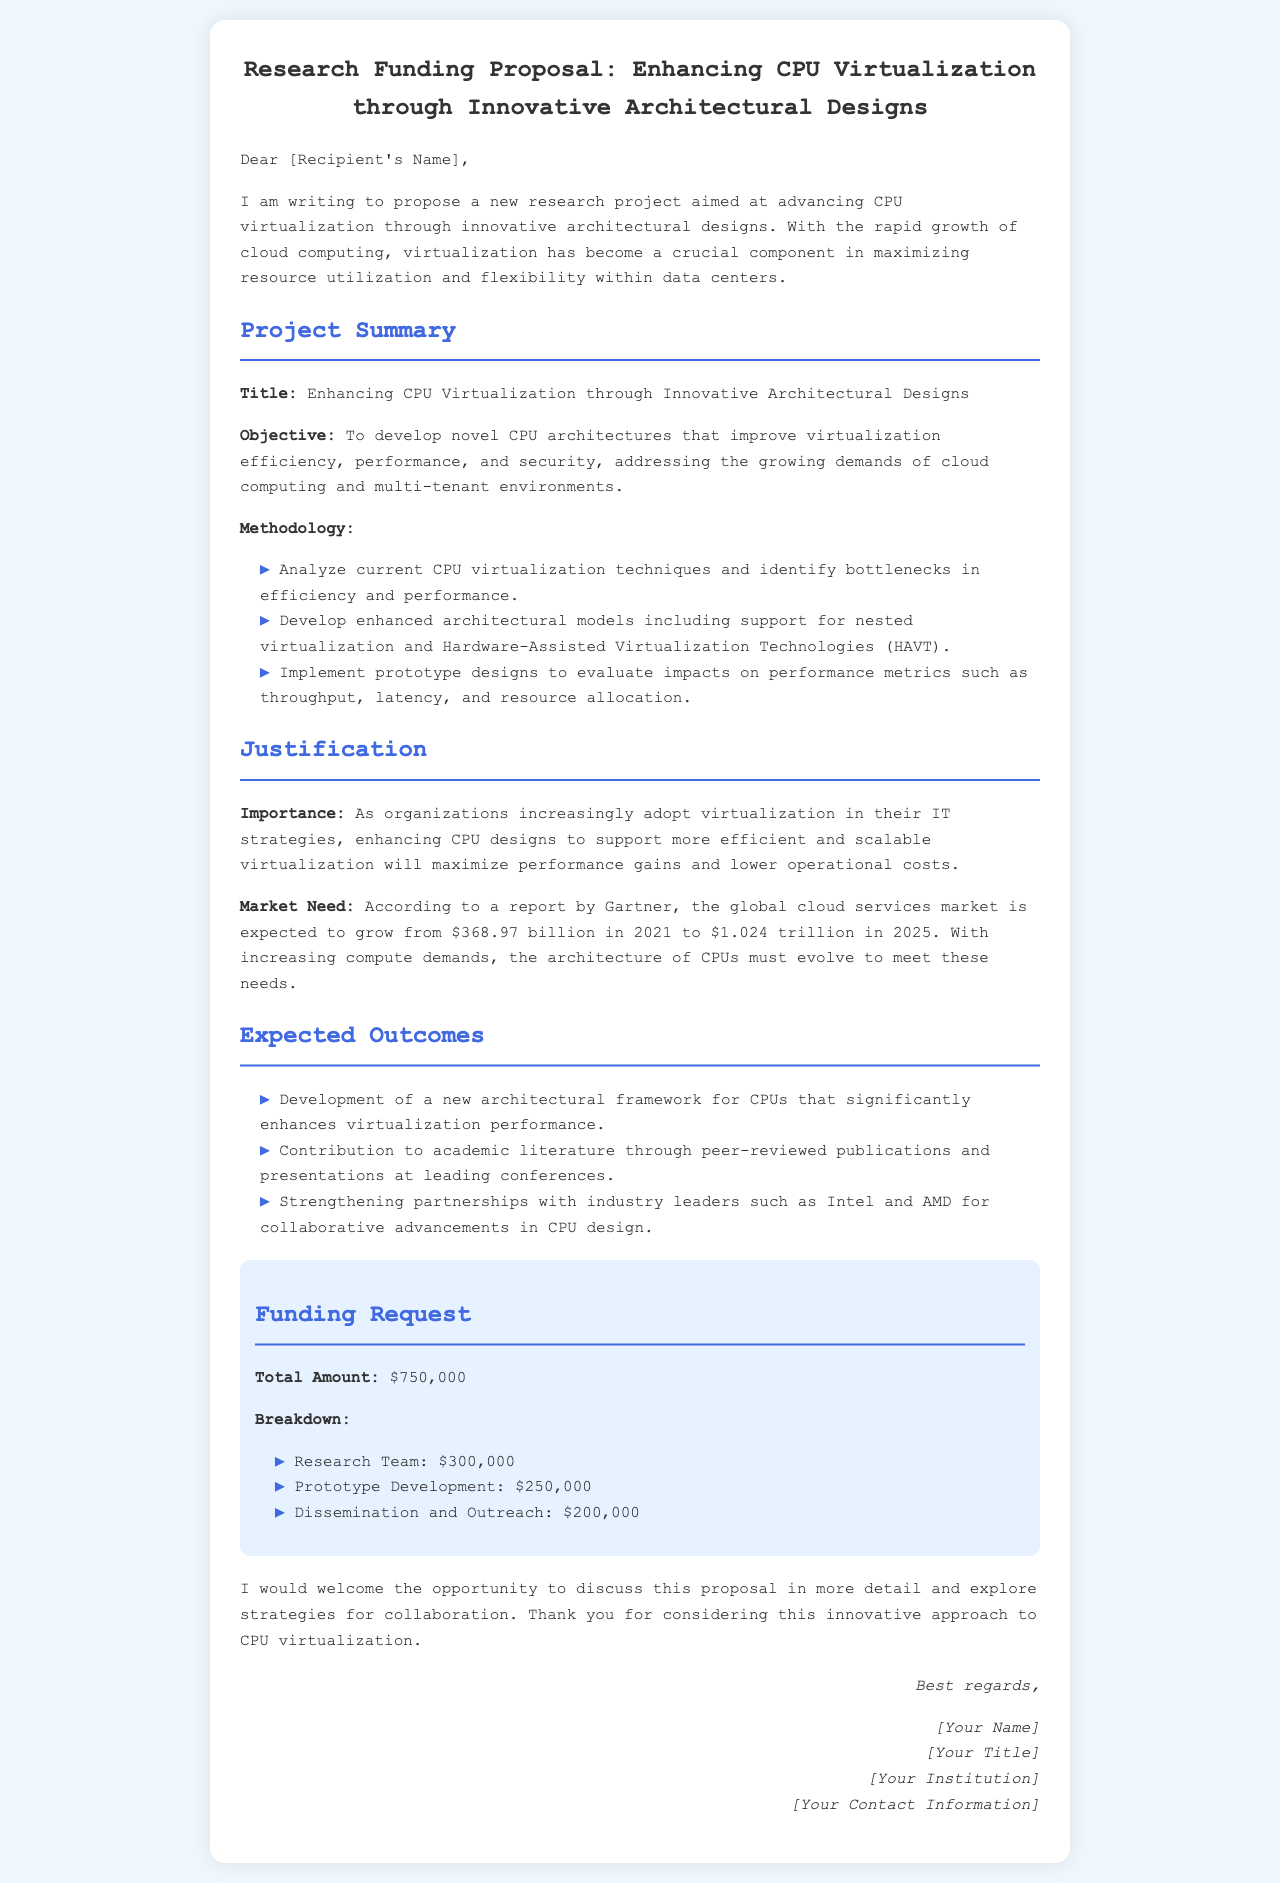What is the title of the project? The title of the project is presented as a clear heading in the document.
Answer: Enhancing CPU Virtualization through Innovative Architectural Designs What is the total amount of funding requested? The total amount of funding requested is specified in the funding section of the document.
Answer: $750,000 What are the expected outcomes mentioned? The expected outcomes are listed in a bulleted format under the corresponding section.
Answer: Development of a new architectural framework for CPUs that significantly enhances virtualization performance What is the objective of the research project? The objective is outlined in a clear statement following the title in the project summary section.
Answer: To develop novel CPU architectures that improve virtualization efficiency, performance, and security How much is allocated for prototype development? The breakdown of the funding request specifies how much is allocated for prototype development.
Answer: $250,000 Why is enhancing CPU designs important? The importance of enhancing CPU designs is stated in the justification section of the document.
Answer: To maximize performance gains and lower operational costs What market trend is mentioned in the proposal? The market need is highlighted with a statistic that summarizes the expected growth in a specific sector.
Answer: The global cloud services market is expected to grow from $368.97 billion in 2021 to $1.024 trillion in 2025 Who are the potential partners mentioned for collaboration? The document mentions specific industry leaders in the context of strengthening partnerships.
Answer: Intel and AMD 